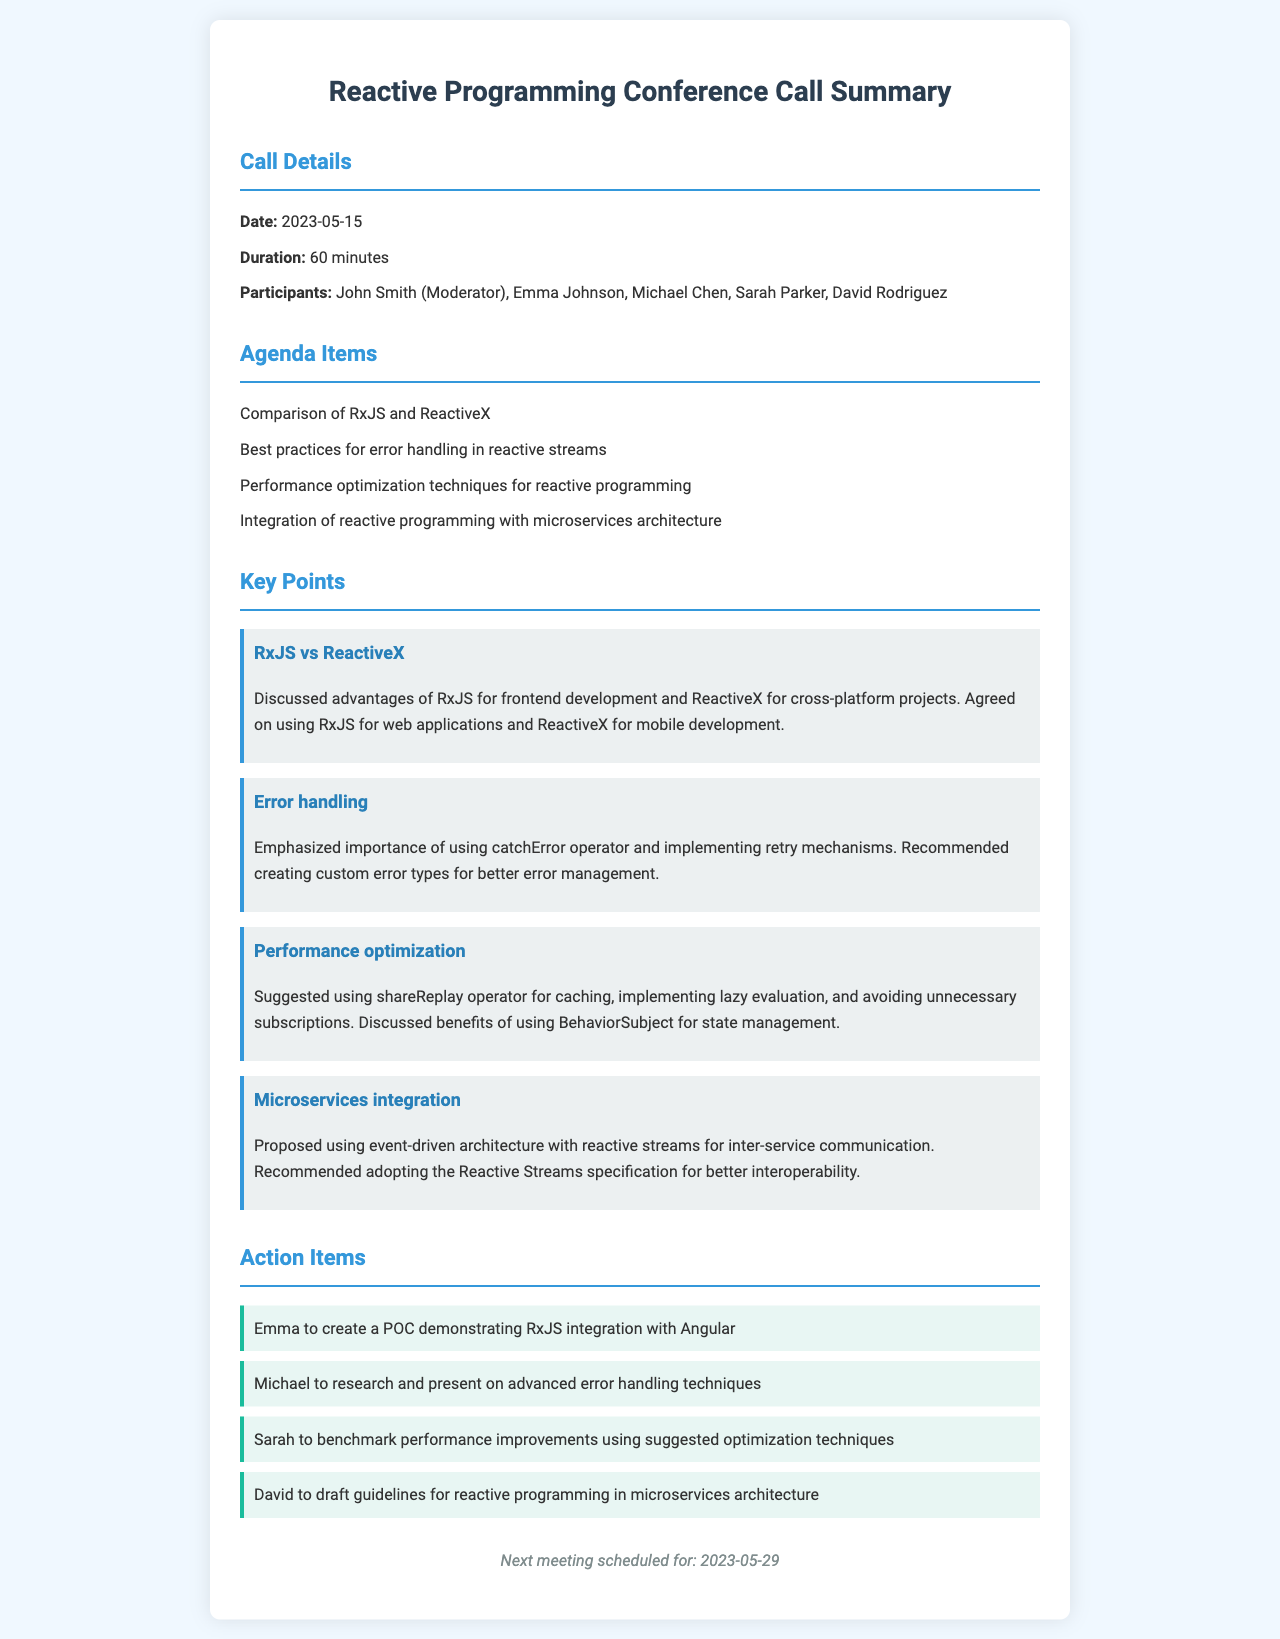what was the date of the conference call? The date is explicitly stated in the document under Call Details.
Answer: 2023-05-15 how long did the conference call last? The duration of the call is mentioned in the Call Details section.
Answer: 60 minutes who moderated the conference call? The moderator's name is listed in the Call Details section.
Answer: John Smith which frameworks were compared during the call? The frameworks discussed are listed under the Agenda Items section.
Answer: RxJS and ReactiveX what was one of the action items assigned to Emma? Emma's action item is specified in the Action Items section.
Answer: create a POC demonstrating RxJS integration with Angular what optimization technique was suggested for caching? The suggested optimization technique for caching is mentioned in the Key Points section.
Answer: shareReplay operator what is the next meeting date? The date for the next meeting is noted in the footer of the document.
Answer: 2023-05-29 who was tasked to research advanced error handling techniques? The individual responsible for this task is listed in the Action Items section.
Answer: Michael what was emphasized as important for error handling? The key point regarding error handling is found in the Key Points section.
Answer: catchError operator what architecture was proposed for microservices integration? The proposed architecture type is mentioned in the Key Points section.
Answer: event-driven architecture 